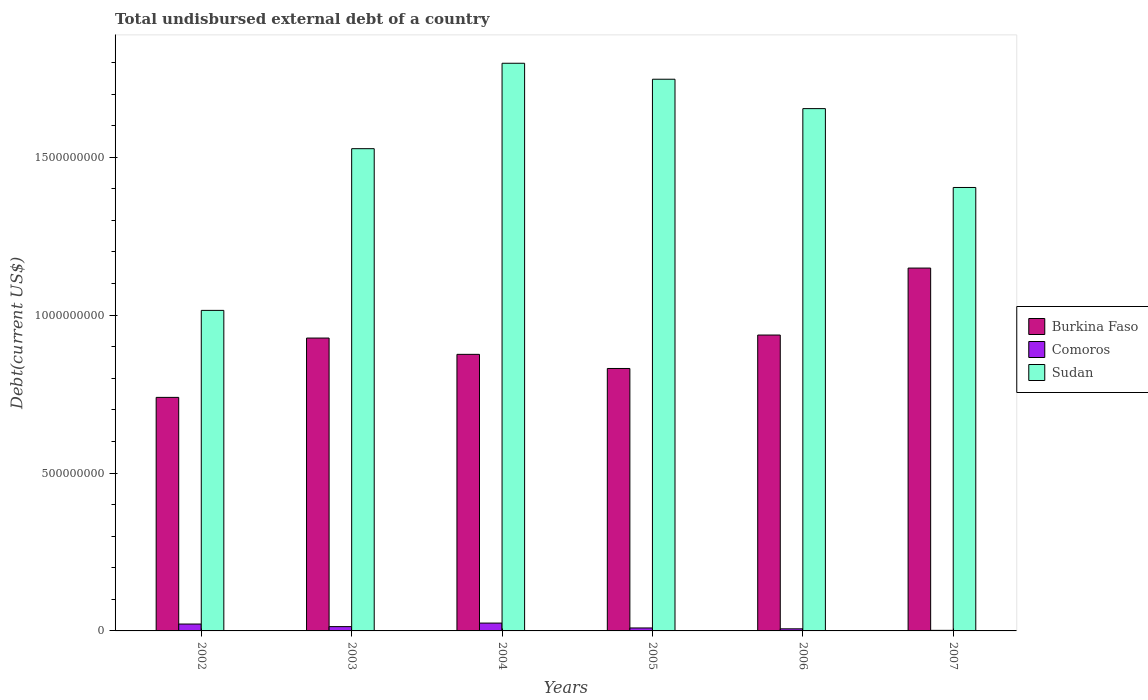How many different coloured bars are there?
Provide a succinct answer. 3. How many bars are there on the 3rd tick from the left?
Offer a very short reply. 3. How many bars are there on the 3rd tick from the right?
Your answer should be compact. 3. In how many cases, is the number of bars for a given year not equal to the number of legend labels?
Offer a very short reply. 0. What is the total undisbursed external debt in Sudan in 2006?
Provide a short and direct response. 1.65e+09. Across all years, what is the maximum total undisbursed external debt in Burkina Faso?
Your answer should be compact. 1.15e+09. Across all years, what is the minimum total undisbursed external debt in Burkina Faso?
Your answer should be compact. 7.40e+08. In which year was the total undisbursed external debt in Sudan maximum?
Your answer should be very brief. 2004. In which year was the total undisbursed external debt in Sudan minimum?
Offer a terse response. 2002. What is the total total undisbursed external debt in Sudan in the graph?
Your answer should be compact. 9.15e+09. What is the difference between the total undisbursed external debt in Sudan in 2003 and that in 2007?
Your response must be concise. 1.23e+08. What is the difference between the total undisbursed external debt in Burkina Faso in 2003 and the total undisbursed external debt in Sudan in 2002?
Your response must be concise. -8.76e+07. What is the average total undisbursed external debt in Burkina Faso per year?
Keep it short and to the point. 9.10e+08. In the year 2006, what is the difference between the total undisbursed external debt in Sudan and total undisbursed external debt in Burkina Faso?
Keep it short and to the point. 7.17e+08. In how many years, is the total undisbursed external debt in Comoros greater than 100000000 US$?
Keep it short and to the point. 0. What is the ratio of the total undisbursed external debt in Burkina Faso in 2002 to that in 2005?
Keep it short and to the point. 0.89. What is the difference between the highest and the second highest total undisbursed external debt in Comoros?
Ensure brevity in your answer.  3.01e+06. What is the difference between the highest and the lowest total undisbursed external debt in Sudan?
Give a very brief answer. 7.83e+08. In how many years, is the total undisbursed external debt in Comoros greater than the average total undisbursed external debt in Comoros taken over all years?
Your response must be concise. 3. Is the sum of the total undisbursed external debt in Burkina Faso in 2006 and 2007 greater than the maximum total undisbursed external debt in Comoros across all years?
Your answer should be very brief. Yes. What does the 3rd bar from the left in 2005 represents?
Give a very brief answer. Sudan. What does the 3rd bar from the right in 2002 represents?
Provide a short and direct response. Burkina Faso. How many bars are there?
Your answer should be very brief. 18. Are all the bars in the graph horizontal?
Provide a succinct answer. No. How many years are there in the graph?
Provide a short and direct response. 6. Are the values on the major ticks of Y-axis written in scientific E-notation?
Provide a short and direct response. No. How many legend labels are there?
Your response must be concise. 3. How are the legend labels stacked?
Provide a short and direct response. Vertical. What is the title of the graph?
Ensure brevity in your answer.  Total undisbursed external debt of a country. Does "Sweden" appear as one of the legend labels in the graph?
Offer a very short reply. No. What is the label or title of the X-axis?
Give a very brief answer. Years. What is the label or title of the Y-axis?
Your response must be concise. Debt(current US$). What is the Debt(current US$) in Burkina Faso in 2002?
Your response must be concise. 7.40e+08. What is the Debt(current US$) of Comoros in 2002?
Provide a short and direct response. 2.18e+07. What is the Debt(current US$) of Sudan in 2002?
Provide a succinct answer. 1.02e+09. What is the Debt(current US$) of Burkina Faso in 2003?
Offer a terse response. 9.27e+08. What is the Debt(current US$) of Comoros in 2003?
Your answer should be very brief. 1.36e+07. What is the Debt(current US$) of Sudan in 2003?
Make the answer very short. 1.53e+09. What is the Debt(current US$) of Burkina Faso in 2004?
Provide a short and direct response. 8.76e+08. What is the Debt(current US$) of Comoros in 2004?
Make the answer very short. 2.48e+07. What is the Debt(current US$) of Sudan in 2004?
Make the answer very short. 1.80e+09. What is the Debt(current US$) of Burkina Faso in 2005?
Your answer should be compact. 8.31e+08. What is the Debt(current US$) of Comoros in 2005?
Your answer should be compact. 9.37e+06. What is the Debt(current US$) of Sudan in 2005?
Keep it short and to the point. 1.75e+09. What is the Debt(current US$) of Burkina Faso in 2006?
Offer a very short reply. 9.37e+08. What is the Debt(current US$) in Comoros in 2006?
Provide a short and direct response. 6.64e+06. What is the Debt(current US$) in Sudan in 2006?
Ensure brevity in your answer.  1.65e+09. What is the Debt(current US$) in Burkina Faso in 2007?
Give a very brief answer. 1.15e+09. What is the Debt(current US$) in Comoros in 2007?
Offer a terse response. 1.80e+06. What is the Debt(current US$) of Sudan in 2007?
Offer a terse response. 1.40e+09. Across all years, what is the maximum Debt(current US$) of Burkina Faso?
Your answer should be very brief. 1.15e+09. Across all years, what is the maximum Debt(current US$) of Comoros?
Your answer should be very brief. 2.48e+07. Across all years, what is the maximum Debt(current US$) in Sudan?
Give a very brief answer. 1.80e+09. Across all years, what is the minimum Debt(current US$) of Burkina Faso?
Provide a short and direct response. 7.40e+08. Across all years, what is the minimum Debt(current US$) in Comoros?
Offer a very short reply. 1.80e+06. Across all years, what is the minimum Debt(current US$) of Sudan?
Your answer should be compact. 1.02e+09. What is the total Debt(current US$) of Burkina Faso in the graph?
Your answer should be compact. 5.46e+09. What is the total Debt(current US$) of Comoros in the graph?
Provide a short and direct response. 7.81e+07. What is the total Debt(current US$) of Sudan in the graph?
Give a very brief answer. 9.15e+09. What is the difference between the Debt(current US$) in Burkina Faso in 2002 and that in 2003?
Your answer should be compact. -1.88e+08. What is the difference between the Debt(current US$) of Comoros in 2002 and that in 2003?
Offer a terse response. 8.18e+06. What is the difference between the Debt(current US$) in Sudan in 2002 and that in 2003?
Give a very brief answer. -5.12e+08. What is the difference between the Debt(current US$) in Burkina Faso in 2002 and that in 2004?
Provide a succinct answer. -1.36e+08. What is the difference between the Debt(current US$) of Comoros in 2002 and that in 2004?
Your answer should be compact. -3.01e+06. What is the difference between the Debt(current US$) of Sudan in 2002 and that in 2004?
Your response must be concise. -7.83e+08. What is the difference between the Debt(current US$) of Burkina Faso in 2002 and that in 2005?
Offer a terse response. -9.16e+07. What is the difference between the Debt(current US$) in Comoros in 2002 and that in 2005?
Your response must be concise. 1.24e+07. What is the difference between the Debt(current US$) of Sudan in 2002 and that in 2005?
Ensure brevity in your answer.  -7.32e+08. What is the difference between the Debt(current US$) of Burkina Faso in 2002 and that in 2006?
Your answer should be very brief. -1.97e+08. What is the difference between the Debt(current US$) in Comoros in 2002 and that in 2006?
Provide a short and direct response. 1.52e+07. What is the difference between the Debt(current US$) in Sudan in 2002 and that in 2006?
Keep it short and to the point. -6.39e+08. What is the difference between the Debt(current US$) of Burkina Faso in 2002 and that in 2007?
Your response must be concise. -4.09e+08. What is the difference between the Debt(current US$) in Comoros in 2002 and that in 2007?
Make the answer very short. 2.00e+07. What is the difference between the Debt(current US$) in Sudan in 2002 and that in 2007?
Ensure brevity in your answer.  -3.89e+08. What is the difference between the Debt(current US$) of Burkina Faso in 2003 and that in 2004?
Keep it short and to the point. 5.16e+07. What is the difference between the Debt(current US$) in Comoros in 2003 and that in 2004?
Your response must be concise. -1.12e+07. What is the difference between the Debt(current US$) in Sudan in 2003 and that in 2004?
Provide a short and direct response. -2.71e+08. What is the difference between the Debt(current US$) in Burkina Faso in 2003 and that in 2005?
Your response must be concise. 9.63e+07. What is the difference between the Debt(current US$) of Comoros in 2003 and that in 2005?
Provide a short and direct response. 4.26e+06. What is the difference between the Debt(current US$) in Sudan in 2003 and that in 2005?
Provide a short and direct response. -2.20e+08. What is the difference between the Debt(current US$) of Burkina Faso in 2003 and that in 2006?
Offer a terse response. -9.56e+06. What is the difference between the Debt(current US$) in Comoros in 2003 and that in 2006?
Keep it short and to the point. 6.99e+06. What is the difference between the Debt(current US$) in Sudan in 2003 and that in 2006?
Your response must be concise. -1.27e+08. What is the difference between the Debt(current US$) of Burkina Faso in 2003 and that in 2007?
Keep it short and to the point. -2.22e+08. What is the difference between the Debt(current US$) of Comoros in 2003 and that in 2007?
Your answer should be very brief. 1.18e+07. What is the difference between the Debt(current US$) in Sudan in 2003 and that in 2007?
Offer a terse response. 1.23e+08. What is the difference between the Debt(current US$) in Burkina Faso in 2004 and that in 2005?
Your response must be concise. 4.47e+07. What is the difference between the Debt(current US$) of Comoros in 2004 and that in 2005?
Give a very brief answer. 1.55e+07. What is the difference between the Debt(current US$) of Sudan in 2004 and that in 2005?
Provide a succinct answer. 5.05e+07. What is the difference between the Debt(current US$) in Burkina Faso in 2004 and that in 2006?
Offer a terse response. -6.12e+07. What is the difference between the Debt(current US$) in Comoros in 2004 and that in 2006?
Your response must be concise. 1.82e+07. What is the difference between the Debt(current US$) in Sudan in 2004 and that in 2006?
Offer a terse response. 1.44e+08. What is the difference between the Debt(current US$) of Burkina Faso in 2004 and that in 2007?
Keep it short and to the point. -2.73e+08. What is the difference between the Debt(current US$) in Comoros in 2004 and that in 2007?
Make the answer very short. 2.30e+07. What is the difference between the Debt(current US$) of Sudan in 2004 and that in 2007?
Your response must be concise. 3.93e+08. What is the difference between the Debt(current US$) of Burkina Faso in 2005 and that in 2006?
Your answer should be very brief. -1.06e+08. What is the difference between the Debt(current US$) in Comoros in 2005 and that in 2006?
Make the answer very short. 2.73e+06. What is the difference between the Debt(current US$) of Sudan in 2005 and that in 2006?
Your answer should be compact. 9.31e+07. What is the difference between the Debt(current US$) of Burkina Faso in 2005 and that in 2007?
Keep it short and to the point. -3.18e+08. What is the difference between the Debt(current US$) in Comoros in 2005 and that in 2007?
Keep it short and to the point. 7.57e+06. What is the difference between the Debt(current US$) of Sudan in 2005 and that in 2007?
Keep it short and to the point. 3.43e+08. What is the difference between the Debt(current US$) in Burkina Faso in 2006 and that in 2007?
Give a very brief answer. -2.12e+08. What is the difference between the Debt(current US$) in Comoros in 2006 and that in 2007?
Offer a very short reply. 4.84e+06. What is the difference between the Debt(current US$) in Sudan in 2006 and that in 2007?
Offer a terse response. 2.50e+08. What is the difference between the Debt(current US$) of Burkina Faso in 2002 and the Debt(current US$) of Comoros in 2003?
Provide a short and direct response. 7.26e+08. What is the difference between the Debt(current US$) of Burkina Faso in 2002 and the Debt(current US$) of Sudan in 2003?
Keep it short and to the point. -7.88e+08. What is the difference between the Debt(current US$) in Comoros in 2002 and the Debt(current US$) in Sudan in 2003?
Your response must be concise. -1.51e+09. What is the difference between the Debt(current US$) in Burkina Faso in 2002 and the Debt(current US$) in Comoros in 2004?
Make the answer very short. 7.15e+08. What is the difference between the Debt(current US$) of Burkina Faso in 2002 and the Debt(current US$) of Sudan in 2004?
Your answer should be compact. -1.06e+09. What is the difference between the Debt(current US$) of Comoros in 2002 and the Debt(current US$) of Sudan in 2004?
Provide a succinct answer. -1.78e+09. What is the difference between the Debt(current US$) in Burkina Faso in 2002 and the Debt(current US$) in Comoros in 2005?
Offer a very short reply. 7.30e+08. What is the difference between the Debt(current US$) in Burkina Faso in 2002 and the Debt(current US$) in Sudan in 2005?
Make the answer very short. -1.01e+09. What is the difference between the Debt(current US$) of Comoros in 2002 and the Debt(current US$) of Sudan in 2005?
Your answer should be very brief. -1.73e+09. What is the difference between the Debt(current US$) in Burkina Faso in 2002 and the Debt(current US$) in Comoros in 2006?
Your answer should be compact. 7.33e+08. What is the difference between the Debt(current US$) of Burkina Faso in 2002 and the Debt(current US$) of Sudan in 2006?
Keep it short and to the point. -9.14e+08. What is the difference between the Debt(current US$) in Comoros in 2002 and the Debt(current US$) in Sudan in 2006?
Your response must be concise. -1.63e+09. What is the difference between the Debt(current US$) of Burkina Faso in 2002 and the Debt(current US$) of Comoros in 2007?
Offer a terse response. 7.38e+08. What is the difference between the Debt(current US$) in Burkina Faso in 2002 and the Debt(current US$) in Sudan in 2007?
Provide a short and direct response. -6.65e+08. What is the difference between the Debt(current US$) in Comoros in 2002 and the Debt(current US$) in Sudan in 2007?
Ensure brevity in your answer.  -1.38e+09. What is the difference between the Debt(current US$) of Burkina Faso in 2003 and the Debt(current US$) of Comoros in 2004?
Ensure brevity in your answer.  9.03e+08. What is the difference between the Debt(current US$) in Burkina Faso in 2003 and the Debt(current US$) in Sudan in 2004?
Provide a succinct answer. -8.70e+08. What is the difference between the Debt(current US$) in Comoros in 2003 and the Debt(current US$) in Sudan in 2004?
Your answer should be very brief. -1.78e+09. What is the difference between the Debt(current US$) of Burkina Faso in 2003 and the Debt(current US$) of Comoros in 2005?
Make the answer very short. 9.18e+08. What is the difference between the Debt(current US$) in Burkina Faso in 2003 and the Debt(current US$) in Sudan in 2005?
Your answer should be compact. -8.20e+08. What is the difference between the Debt(current US$) of Comoros in 2003 and the Debt(current US$) of Sudan in 2005?
Provide a short and direct response. -1.73e+09. What is the difference between the Debt(current US$) of Burkina Faso in 2003 and the Debt(current US$) of Comoros in 2006?
Keep it short and to the point. 9.21e+08. What is the difference between the Debt(current US$) in Burkina Faso in 2003 and the Debt(current US$) in Sudan in 2006?
Make the answer very short. -7.27e+08. What is the difference between the Debt(current US$) of Comoros in 2003 and the Debt(current US$) of Sudan in 2006?
Your answer should be compact. -1.64e+09. What is the difference between the Debt(current US$) of Burkina Faso in 2003 and the Debt(current US$) of Comoros in 2007?
Give a very brief answer. 9.26e+08. What is the difference between the Debt(current US$) in Burkina Faso in 2003 and the Debt(current US$) in Sudan in 2007?
Ensure brevity in your answer.  -4.77e+08. What is the difference between the Debt(current US$) in Comoros in 2003 and the Debt(current US$) in Sudan in 2007?
Your response must be concise. -1.39e+09. What is the difference between the Debt(current US$) in Burkina Faso in 2004 and the Debt(current US$) in Comoros in 2005?
Give a very brief answer. 8.66e+08. What is the difference between the Debt(current US$) in Burkina Faso in 2004 and the Debt(current US$) in Sudan in 2005?
Offer a very short reply. -8.71e+08. What is the difference between the Debt(current US$) of Comoros in 2004 and the Debt(current US$) of Sudan in 2005?
Keep it short and to the point. -1.72e+09. What is the difference between the Debt(current US$) in Burkina Faso in 2004 and the Debt(current US$) in Comoros in 2006?
Give a very brief answer. 8.69e+08. What is the difference between the Debt(current US$) in Burkina Faso in 2004 and the Debt(current US$) in Sudan in 2006?
Ensure brevity in your answer.  -7.78e+08. What is the difference between the Debt(current US$) of Comoros in 2004 and the Debt(current US$) of Sudan in 2006?
Ensure brevity in your answer.  -1.63e+09. What is the difference between the Debt(current US$) in Burkina Faso in 2004 and the Debt(current US$) in Comoros in 2007?
Ensure brevity in your answer.  8.74e+08. What is the difference between the Debt(current US$) in Burkina Faso in 2004 and the Debt(current US$) in Sudan in 2007?
Make the answer very short. -5.28e+08. What is the difference between the Debt(current US$) of Comoros in 2004 and the Debt(current US$) of Sudan in 2007?
Provide a short and direct response. -1.38e+09. What is the difference between the Debt(current US$) of Burkina Faso in 2005 and the Debt(current US$) of Comoros in 2006?
Provide a succinct answer. 8.24e+08. What is the difference between the Debt(current US$) in Burkina Faso in 2005 and the Debt(current US$) in Sudan in 2006?
Your response must be concise. -8.23e+08. What is the difference between the Debt(current US$) of Comoros in 2005 and the Debt(current US$) of Sudan in 2006?
Give a very brief answer. -1.64e+09. What is the difference between the Debt(current US$) in Burkina Faso in 2005 and the Debt(current US$) in Comoros in 2007?
Your response must be concise. 8.29e+08. What is the difference between the Debt(current US$) of Burkina Faso in 2005 and the Debt(current US$) of Sudan in 2007?
Give a very brief answer. -5.73e+08. What is the difference between the Debt(current US$) in Comoros in 2005 and the Debt(current US$) in Sudan in 2007?
Offer a very short reply. -1.39e+09. What is the difference between the Debt(current US$) in Burkina Faso in 2006 and the Debt(current US$) in Comoros in 2007?
Offer a very short reply. 9.35e+08. What is the difference between the Debt(current US$) of Burkina Faso in 2006 and the Debt(current US$) of Sudan in 2007?
Offer a terse response. -4.67e+08. What is the difference between the Debt(current US$) in Comoros in 2006 and the Debt(current US$) in Sudan in 2007?
Ensure brevity in your answer.  -1.40e+09. What is the average Debt(current US$) of Burkina Faso per year?
Keep it short and to the point. 9.10e+08. What is the average Debt(current US$) in Comoros per year?
Make the answer very short. 1.30e+07. What is the average Debt(current US$) of Sudan per year?
Provide a short and direct response. 1.52e+09. In the year 2002, what is the difference between the Debt(current US$) of Burkina Faso and Debt(current US$) of Comoros?
Offer a very short reply. 7.18e+08. In the year 2002, what is the difference between the Debt(current US$) of Burkina Faso and Debt(current US$) of Sudan?
Give a very brief answer. -2.76e+08. In the year 2002, what is the difference between the Debt(current US$) of Comoros and Debt(current US$) of Sudan?
Provide a succinct answer. -9.93e+08. In the year 2003, what is the difference between the Debt(current US$) of Burkina Faso and Debt(current US$) of Comoros?
Make the answer very short. 9.14e+08. In the year 2003, what is the difference between the Debt(current US$) in Burkina Faso and Debt(current US$) in Sudan?
Provide a short and direct response. -6.00e+08. In the year 2003, what is the difference between the Debt(current US$) in Comoros and Debt(current US$) in Sudan?
Your answer should be compact. -1.51e+09. In the year 2004, what is the difference between the Debt(current US$) in Burkina Faso and Debt(current US$) in Comoros?
Give a very brief answer. 8.51e+08. In the year 2004, what is the difference between the Debt(current US$) in Burkina Faso and Debt(current US$) in Sudan?
Keep it short and to the point. -9.22e+08. In the year 2004, what is the difference between the Debt(current US$) of Comoros and Debt(current US$) of Sudan?
Offer a terse response. -1.77e+09. In the year 2005, what is the difference between the Debt(current US$) in Burkina Faso and Debt(current US$) in Comoros?
Offer a very short reply. 8.22e+08. In the year 2005, what is the difference between the Debt(current US$) of Burkina Faso and Debt(current US$) of Sudan?
Ensure brevity in your answer.  -9.16e+08. In the year 2005, what is the difference between the Debt(current US$) in Comoros and Debt(current US$) in Sudan?
Offer a terse response. -1.74e+09. In the year 2006, what is the difference between the Debt(current US$) of Burkina Faso and Debt(current US$) of Comoros?
Keep it short and to the point. 9.30e+08. In the year 2006, what is the difference between the Debt(current US$) of Burkina Faso and Debt(current US$) of Sudan?
Your response must be concise. -7.17e+08. In the year 2006, what is the difference between the Debt(current US$) of Comoros and Debt(current US$) of Sudan?
Make the answer very short. -1.65e+09. In the year 2007, what is the difference between the Debt(current US$) of Burkina Faso and Debt(current US$) of Comoros?
Your answer should be very brief. 1.15e+09. In the year 2007, what is the difference between the Debt(current US$) in Burkina Faso and Debt(current US$) in Sudan?
Make the answer very short. -2.55e+08. In the year 2007, what is the difference between the Debt(current US$) in Comoros and Debt(current US$) in Sudan?
Offer a terse response. -1.40e+09. What is the ratio of the Debt(current US$) of Burkina Faso in 2002 to that in 2003?
Your answer should be compact. 0.8. What is the ratio of the Debt(current US$) of Comoros in 2002 to that in 2003?
Keep it short and to the point. 1.6. What is the ratio of the Debt(current US$) of Sudan in 2002 to that in 2003?
Give a very brief answer. 0.66. What is the ratio of the Debt(current US$) of Burkina Faso in 2002 to that in 2004?
Offer a very short reply. 0.84. What is the ratio of the Debt(current US$) of Comoros in 2002 to that in 2004?
Provide a succinct answer. 0.88. What is the ratio of the Debt(current US$) in Sudan in 2002 to that in 2004?
Your answer should be compact. 0.56. What is the ratio of the Debt(current US$) in Burkina Faso in 2002 to that in 2005?
Offer a terse response. 0.89. What is the ratio of the Debt(current US$) in Comoros in 2002 to that in 2005?
Provide a succinct answer. 2.33. What is the ratio of the Debt(current US$) in Sudan in 2002 to that in 2005?
Provide a short and direct response. 0.58. What is the ratio of the Debt(current US$) in Burkina Faso in 2002 to that in 2006?
Your response must be concise. 0.79. What is the ratio of the Debt(current US$) of Comoros in 2002 to that in 2006?
Give a very brief answer. 3.28. What is the ratio of the Debt(current US$) of Sudan in 2002 to that in 2006?
Provide a succinct answer. 0.61. What is the ratio of the Debt(current US$) of Burkina Faso in 2002 to that in 2007?
Offer a terse response. 0.64. What is the ratio of the Debt(current US$) in Comoros in 2002 to that in 2007?
Provide a succinct answer. 12.08. What is the ratio of the Debt(current US$) in Sudan in 2002 to that in 2007?
Offer a terse response. 0.72. What is the ratio of the Debt(current US$) of Burkina Faso in 2003 to that in 2004?
Your answer should be compact. 1.06. What is the ratio of the Debt(current US$) of Comoros in 2003 to that in 2004?
Offer a terse response. 0.55. What is the ratio of the Debt(current US$) of Sudan in 2003 to that in 2004?
Your answer should be compact. 0.85. What is the ratio of the Debt(current US$) in Burkina Faso in 2003 to that in 2005?
Ensure brevity in your answer.  1.12. What is the ratio of the Debt(current US$) of Comoros in 2003 to that in 2005?
Make the answer very short. 1.45. What is the ratio of the Debt(current US$) in Sudan in 2003 to that in 2005?
Ensure brevity in your answer.  0.87. What is the ratio of the Debt(current US$) in Comoros in 2003 to that in 2006?
Your answer should be very brief. 2.05. What is the ratio of the Debt(current US$) of Sudan in 2003 to that in 2006?
Keep it short and to the point. 0.92. What is the ratio of the Debt(current US$) of Burkina Faso in 2003 to that in 2007?
Your response must be concise. 0.81. What is the ratio of the Debt(current US$) in Comoros in 2003 to that in 2007?
Your answer should be compact. 7.55. What is the ratio of the Debt(current US$) of Sudan in 2003 to that in 2007?
Offer a very short reply. 1.09. What is the ratio of the Debt(current US$) of Burkina Faso in 2004 to that in 2005?
Provide a succinct answer. 1.05. What is the ratio of the Debt(current US$) of Comoros in 2004 to that in 2005?
Offer a very short reply. 2.65. What is the ratio of the Debt(current US$) of Sudan in 2004 to that in 2005?
Make the answer very short. 1.03. What is the ratio of the Debt(current US$) of Burkina Faso in 2004 to that in 2006?
Ensure brevity in your answer.  0.93. What is the ratio of the Debt(current US$) in Comoros in 2004 to that in 2006?
Give a very brief answer. 3.74. What is the ratio of the Debt(current US$) in Sudan in 2004 to that in 2006?
Ensure brevity in your answer.  1.09. What is the ratio of the Debt(current US$) in Burkina Faso in 2004 to that in 2007?
Your answer should be very brief. 0.76. What is the ratio of the Debt(current US$) in Comoros in 2004 to that in 2007?
Keep it short and to the point. 13.75. What is the ratio of the Debt(current US$) in Sudan in 2004 to that in 2007?
Ensure brevity in your answer.  1.28. What is the ratio of the Debt(current US$) in Burkina Faso in 2005 to that in 2006?
Offer a very short reply. 0.89. What is the ratio of the Debt(current US$) in Comoros in 2005 to that in 2006?
Your response must be concise. 1.41. What is the ratio of the Debt(current US$) of Sudan in 2005 to that in 2006?
Offer a terse response. 1.06. What is the ratio of the Debt(current US$) of Burkina Faso in 2005 to that in 2007?
Provide a succinct answer. 0.72. What is the ratio of the Debt(current US$) of Comoros in 2005 to that in 2007?
Provide a short and direct response. 5.19. What is the ratio of the Debt(current US$) of Sudan in 2005 to that in 2007?
Your response must be concise. 1.24. What is the ratio of the Debt(current US$) of Burkina Faso in 2006 to that in 2007?
Offer a terse response. 0.82. What is the ratio of the Debt(current US$) of Comoros in 2006 to that in 2007?
Give a very brief answer. 3.68. What is the ratio of the Debt(current US$) of Sudan in 2006 to that in 2007?
Offer a very short reply. 1.18. What is the difference between the highest and the second highest Debt(current US$) of Burkina Faso?
Ensure brevity in your answer.  2.12e+08. What is the difference between the highest and the second highest Debt(current US$) in Comoros?
Your response must be concise. 3.01e+06. What is the difference between the highest and the second highest Debt(current US$) of Sudan?
Keep it short and to the point. 5.05e+07. What is the difference between the highest and the lowest Debt(current US$) in Burkina Faso?
Offer a very short reply. 4.09e+08. What is the difference between the highest and the lowest Debt(current US$) of Comoros?
Give a very brief answer. 2.30e+07. What is the difference between the highest and the lowest Debt(current US$) of Sudan?
Your answer should be compact. 7.83e+08. 